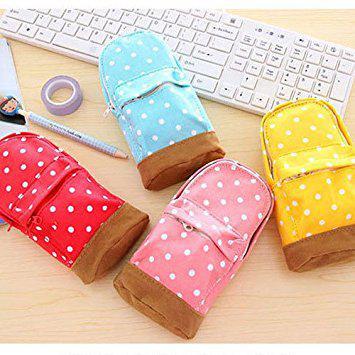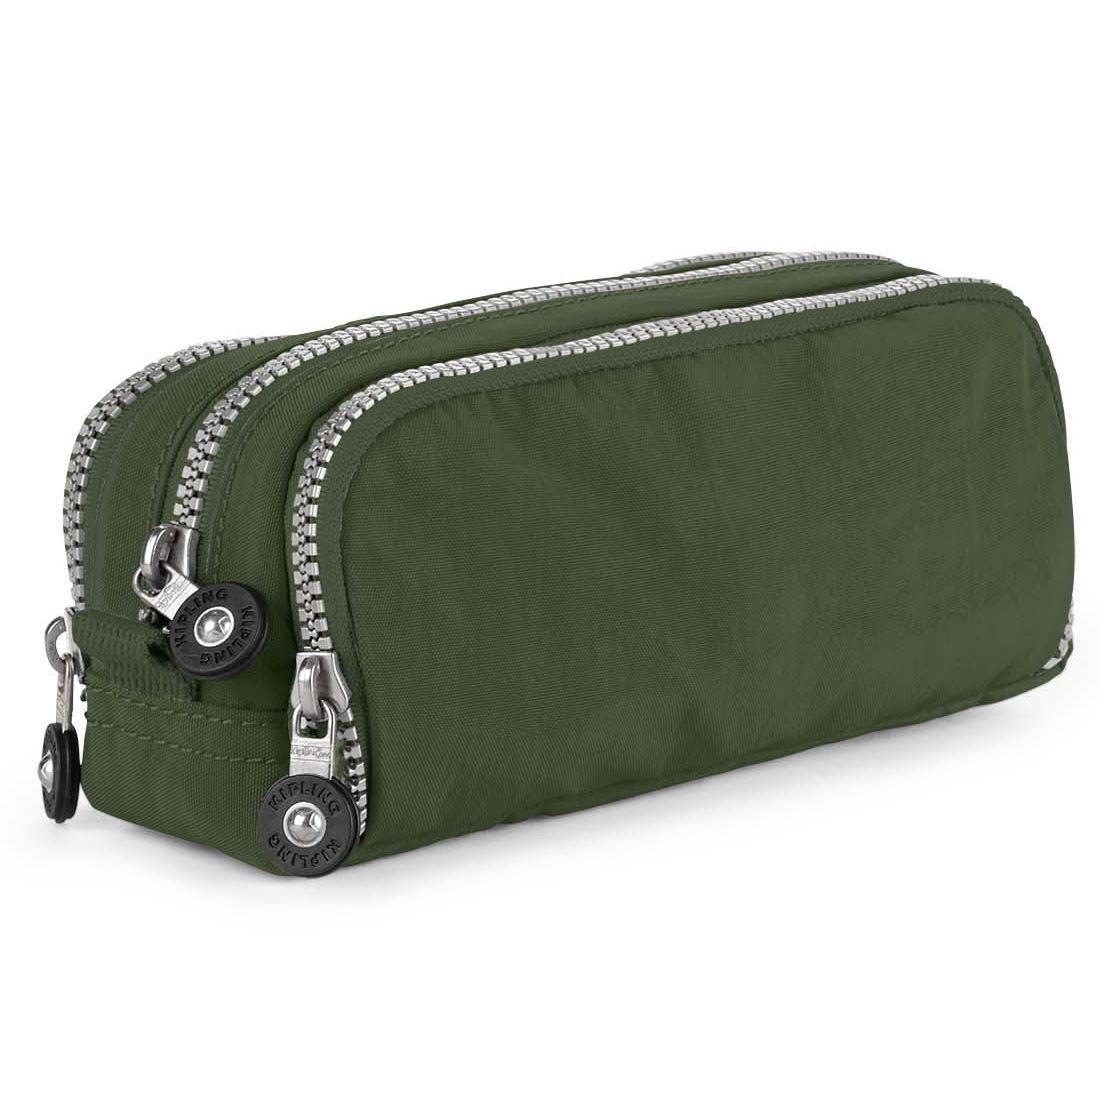The first image is the image on the left, the second image is the image on the right. Examine the images to the left and right. Is the description "There are four bags/pencil-cases in the left image." accurate? Answer yes or no. Yes. The first image is the image on the left, the second image is the image on the right. Assess this claim about the two images: "There are at least 8 zippered pouches.". Correct or not? Answer yes or no. No. 